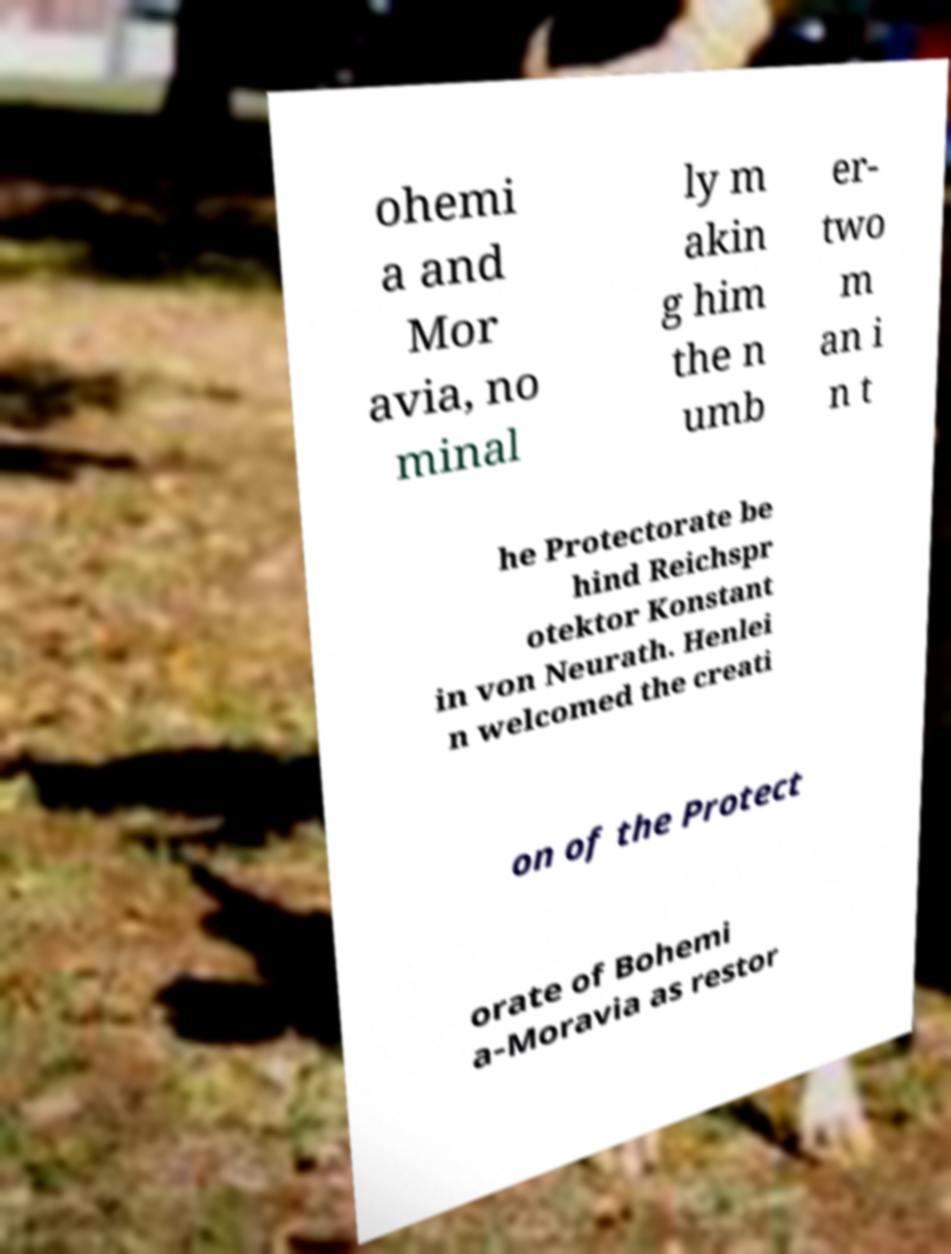For documentation purposes, I need the text within this image transcribed. Could you provide that? ohemi a and Mor avia, no minal ly m akin g him the n umb er- two m an i n t he Protectorate be hind Reichspr otektor Konstant in von Neurath. Henlei n welcomed the creati on of the Protect orate of Bohemi a-Moravia as restor 